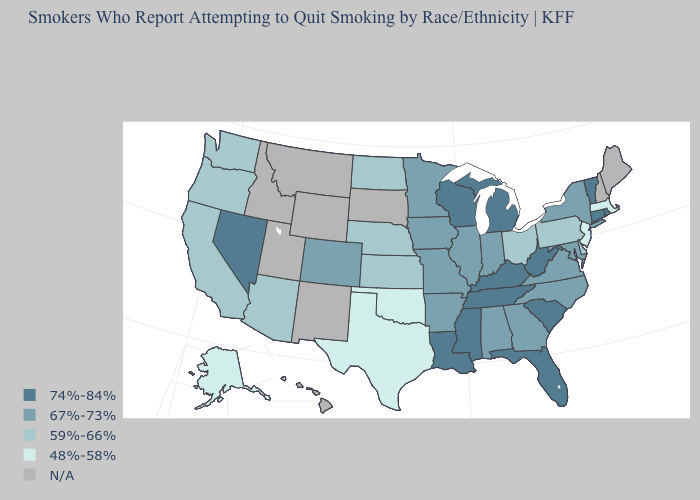Which states have the lowest value in the MidWest?
Short answer required. Kansas, Nebraska, North Dakota, Ohio. Among the states that border Delaware , does Maryland have the highest value?
Concise answer only. Yes. Among the states that border Massachusetts , does Connecticut have the highest value?
Quick response, please. Yes. Name the states that have a value in the range 59%-66%?
Answer briefly. Arizona, California, Delaware, Kansas, Nebraska, North Dakota, Ohio, Oregon, Pennsylvania, Washington. Name the states that have a value in the range 59%-66%?
Be succinct. Arizona, California, Delaware, Kansas, Nebraska, North Dakota, Ohio, Oregon, Pennsylvania, Washington. What is the lowest value in states that border Arkansas?
Quick response, please. 48%-58%. Does the map have missing data?
Be succinct. Yes. Which states have the lowest value in the Northeast?
Keep it brief. Massachusetts, New Jersey. Name the states that have a value in the range 48%-58%?
Give a very brief answer. Alaska, Massachusetts, New Jersey, Oklahoma, Texas. What is the value of Hawaii?
Concise answer only. N/A. What is the value of Louisiana?
Write a very short answer. 74%-84%. Among the states that border Maryland , does Delaware have the lowest value?
Quick response, please. Yes. How many symbols are there in the legend?
Short answer required. 5. What is the value of Florida?
Be succinct. 74%-84%. 